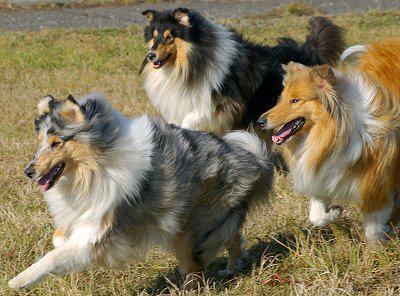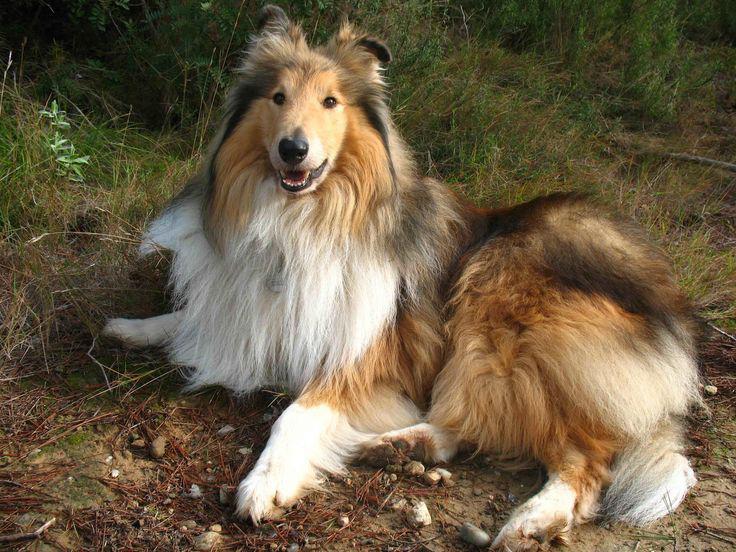The first image is the image on the left, the second image is the image on the right. Assess this claim about the two images: "The dogs on the left are running.". Correct or not? Answer yes or no. Yes. 